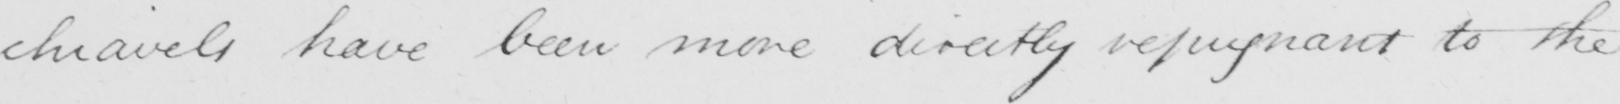Can you tell me what this handwritten text says? -chiavels have been more directly repugnant to the 